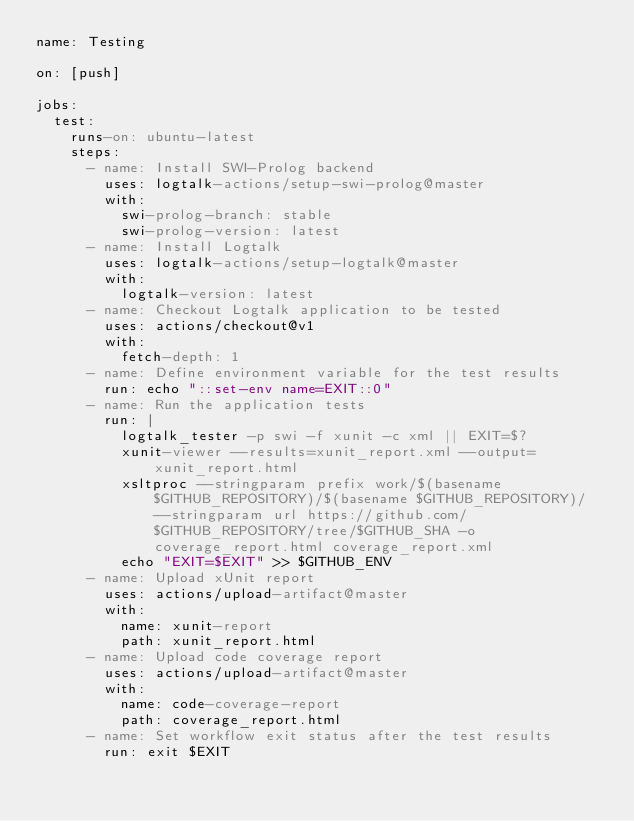<code> <loc_0><loc_0><loc_500><loc_500><_YAML_>name: Testing

on: [push]

jobs:
  test:
    runs-on: ubuntu-latest
    steps:
      - name: Install SWI-Prolog backend
        uses: logtalk-actions/setup-swi-prolog@master
        with:
          swi-prolog-branch: stable
          swi-prolog-version: latest
      - name: Install Logtalk
        uses: logtalk-actions/setup-logtalk@master
        with:
          logtalk-version: latest
      - name: Checkout Logtalk application to be tested
        uses: actions/checkout@v1
        with:
          fetch-depth: 1
      - name: Define environment variable for the test results
        run: echo "::set-env name=EXIT::0"
      - name: Run the application tests
        run: |
          logtalk_tester -p swi -f xunit -c xml || EXIT=$?
          xunit-viewer --results=xunit_report.xml --output=xunit_report.html
          xsltproc --stringparam prefix work/$(basename $GITHUB_REPOSITORY)/$(basename $GITHUB_REPOSITORY)/ --stringparam url https://github.com/$GITHUB_REPOSITORY/tree/$GITHUB_SHA -o coverage_report.html coverage_report.xml
          echo "EXIT=$EXIT" >> $GITHUB_ENV
      - name: Upload xUnit report
        uses: actions/upload-artifact@master
        with:
          name: xunit-report
          path: xunit_report.html
      - name: Upload code coverage report
        uses: actions/upload-artifact@master
        with:
          name: code-coverage-report
          path: coverage_report.html
      - name: Set workflow exit status after the test results
        run: exit $EXIT
</code> 